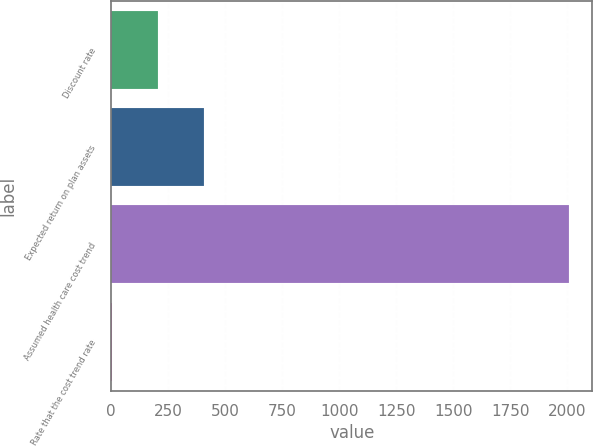Convert chart to OTSL. <chart><loc_0><loc_0><loc_500><loc_500><bar_chart><fcel>Discount rate<fcel>Expected return on plan assets<fcel>Assumed health care cost trend<fcel>Rate that the cost trend rate<nl><fcel>205.5<fcel>406<fcel>2010<fcel>5<nl></chart> 